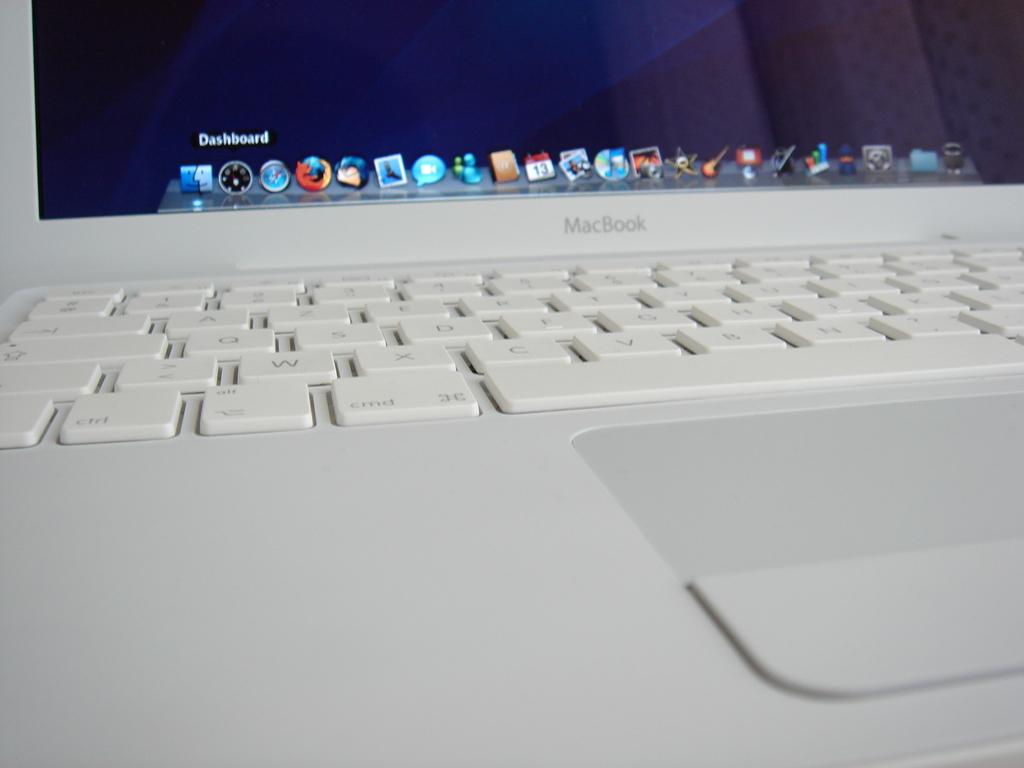Who manufactured this laptop?
Offer a very short reply. Macbook. 